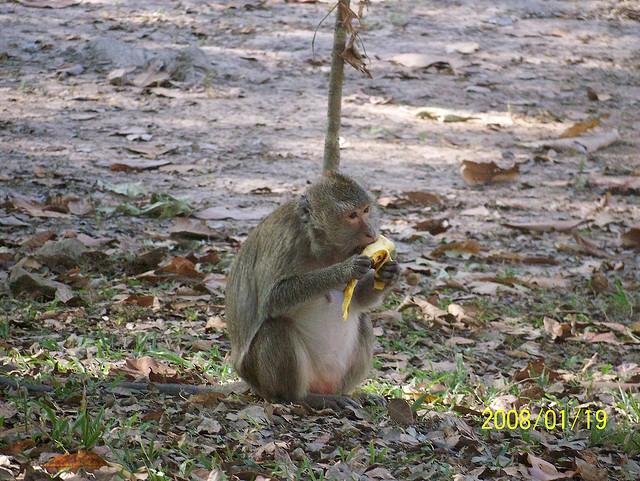What kind of fruit is the monkey eating?
Keep it brief. Banana. Which animal is this?
Give a very brief answer. Monkey. Where is the monkey?
Short answer required. On ground. 